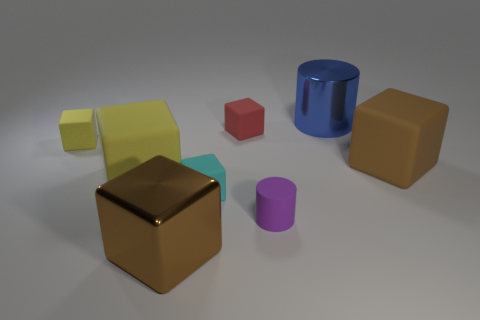Subtract all yellow blocks. How many blocks are left? 4 Subtract all tiny yellow cubes. How many cubes are left? 5 Subtract all gray blocks. Subtract all purple cylinders. How many blocks are left? 6 Add 1 big blue cylinders. How many objects exist? 9 Subtract all cubes. How many objects are left? 2 Subtract all brown metal things. Subtract all purple matte objects. How many objects are left? 6 Add 8 blue metal cylinders. How many blue metal cylinders are left? 9 Add 1 small cyan rubber spheres. How many small cyan rubber spheres exist? 1 Subtract 0 green cylinders. How many objects are left? 8 